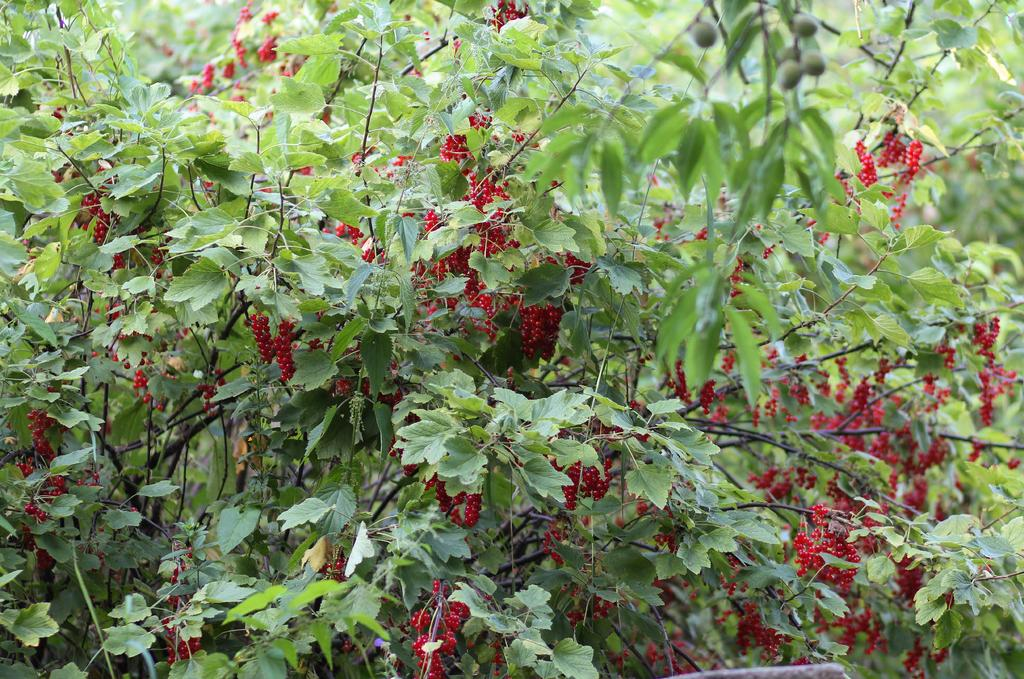What type of living organisms can be seen in the image? Plants can be seen in the image. What additional features can be observed on the plants? The plants have fruits. Can you see an island in the image? There is no island present in the image; it features plants with fruits. What type of tool is being used to harvest the fruits in the image? There is no tool, such as a hammer, present in the image. 